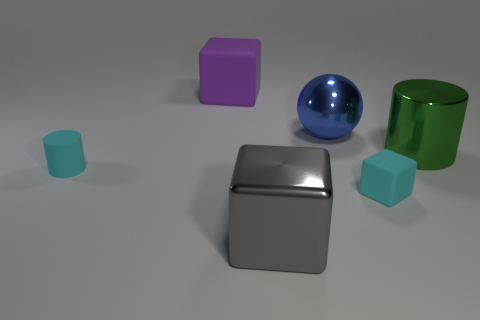Is there any other thing that has the same color as the rubber cylinder?
Provide a succinct answer. Yes. There is a rubber thing that is the same color as the matte cylinder; what is its shape?
Your answer should be very brief. Cube. Is there a shiny object of the same color as the metallic ball?
Your answer should be very brief. No. What is the size of the cylinder that is made of the same material as the tiny cube?
Make the answer very short. Small. What size is the rubber thing that is the same color as the matte cylinder?
Your answer should be compact. Small. What number of other things are there of the same size as the purple rubber block?
Your answer should be very brief. 3. What is the material of the cylinder that is on the right side of the rubber cylinder?
Keep it short and to the point. Metal. The green object that is behind the cyan rubber object right of the large shiny object left of the metal ball is what shape?
Offer a very short reply. Cylinder. Is the rubber cylinder the same size as the cyan block?
Ensure brevity in your answer.  Yes. What number of objects are big gray metallic blocks or metallic cubes on the left side of the cyan cube?
Give a very brief answer. 1. 